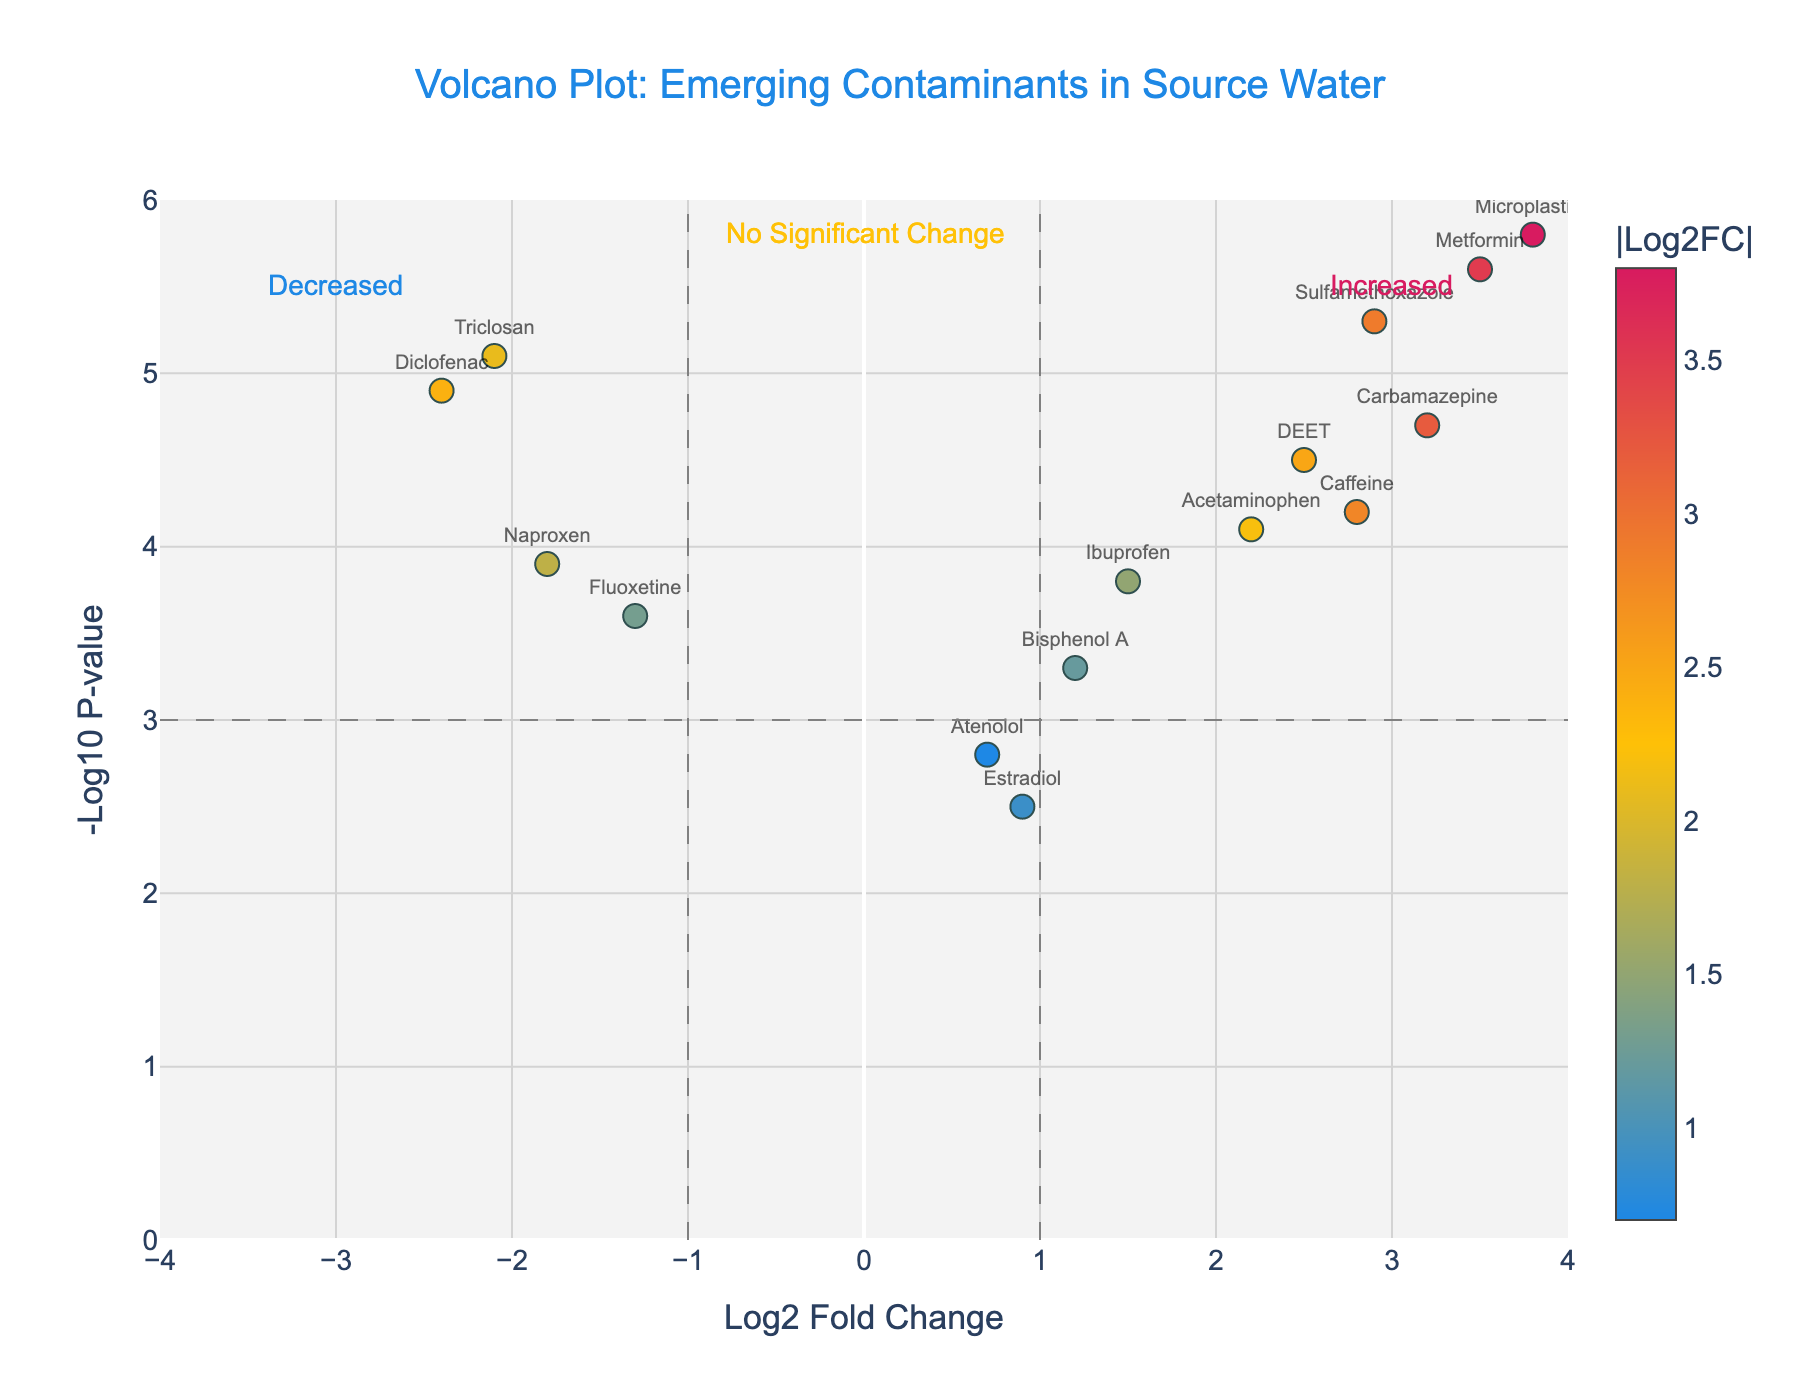What is the title of the plot? The title of the plot is displayed at the top center of the figure, and it reads "Volcano Plot: Emerging Contaminants in Source Water".
Answer: Volcano Plot: Emerging Contaminants in Source Water How many contaminants have a Log2 Fold Change variable greater than 3? To determine this, look for all the points that lie to the right of the vertical line at x=3. Contaminants with Log2 Fold Change greater than 3 are Carbamazepine, Metformin, and Microplastics.
Answer: 3 Which contaminant has the highest Log2 Fold Change in the data? The highest Log2 Fold Change can be found by identifying the point farthest to the right. Microplastics, at a Log2 Fold Change of 3.8, has the highest value.
Answer: Microplastics Which contaminant shows the most significant p-value change? The most significant p-value change is shown by the point with the highest -log10(p-value), which is Microplastics with a -log10(p-value) of 5.8.
Answer: Microplastics Which contaminants show a decrease in concentration? Decreases in concentration are represented by negative Log2 Fold Change values. The contaminants are Triclosan, Naproxen, Diclofenac, and Fluoxetine.
Answer: Triclosan, Naproxen, Diclofenac, Fluoxetine What is the range of the x-axis in the plot? The specified range of the x-axis is visible from the labeled ticks, which span from -4 to 4.
Answer: -4 to 4 How many contaminants have both a high significance (greater than 3 in -log10(p-value)) and increased concentration (positive Log2 Fold Change)? The contaminants with a -log10(p-value) greater than 3 and positive Log2 Fold Change are Caffeine, Ibuprofen, Carbamazepine, DEET, Sulfamethoxazole, Metformin, and Acetaminophen.
Answer: 7 Compare the Log2 Fold Change values of Caffeine and Acetaminophen. Which one is higher? The Log2 Fold Change of Caffeine is 2.8, while for Acetaminophen it is 2.2. Caffeine is higher.
Answer: Caffeine Which contaminant is closest to the 'No Significant Change' line indicated on the plot? 'No Significant Change' is annotated at a Log2 Fold Change of 0. The closest data point to this line is Estradiol with a Log2 Fold Change of 0.9.
Answer: Estradiol 